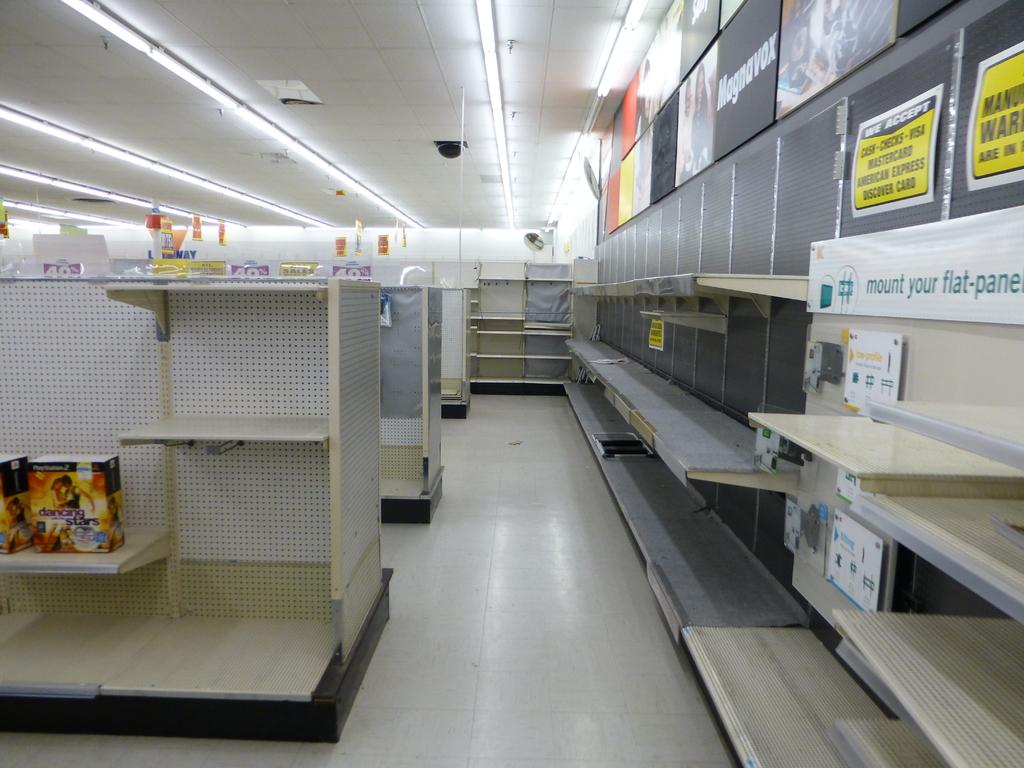<image>
Describe the image concisely. An empty retail store with shelves and various signs that indicates products that were sold and forms of payment accepted. 